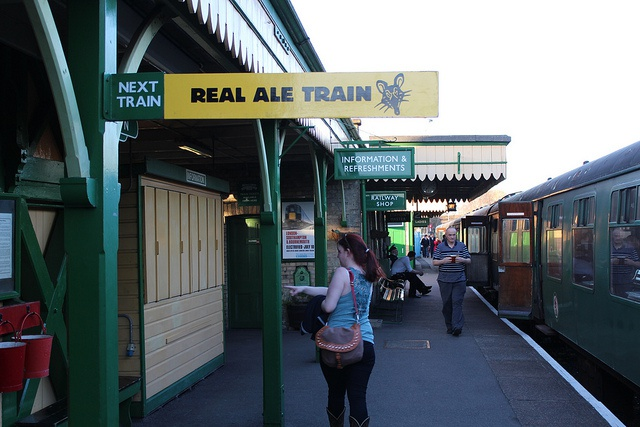Describe the objects in this image and their specific colors. I can see train in black, gray, and blue tones, people in black, blue, and gray tones, people in black, navy, and gray tones, handbag in black, purple, and maroon tones, and bench in black, gray, and darkgray tones in this image. 